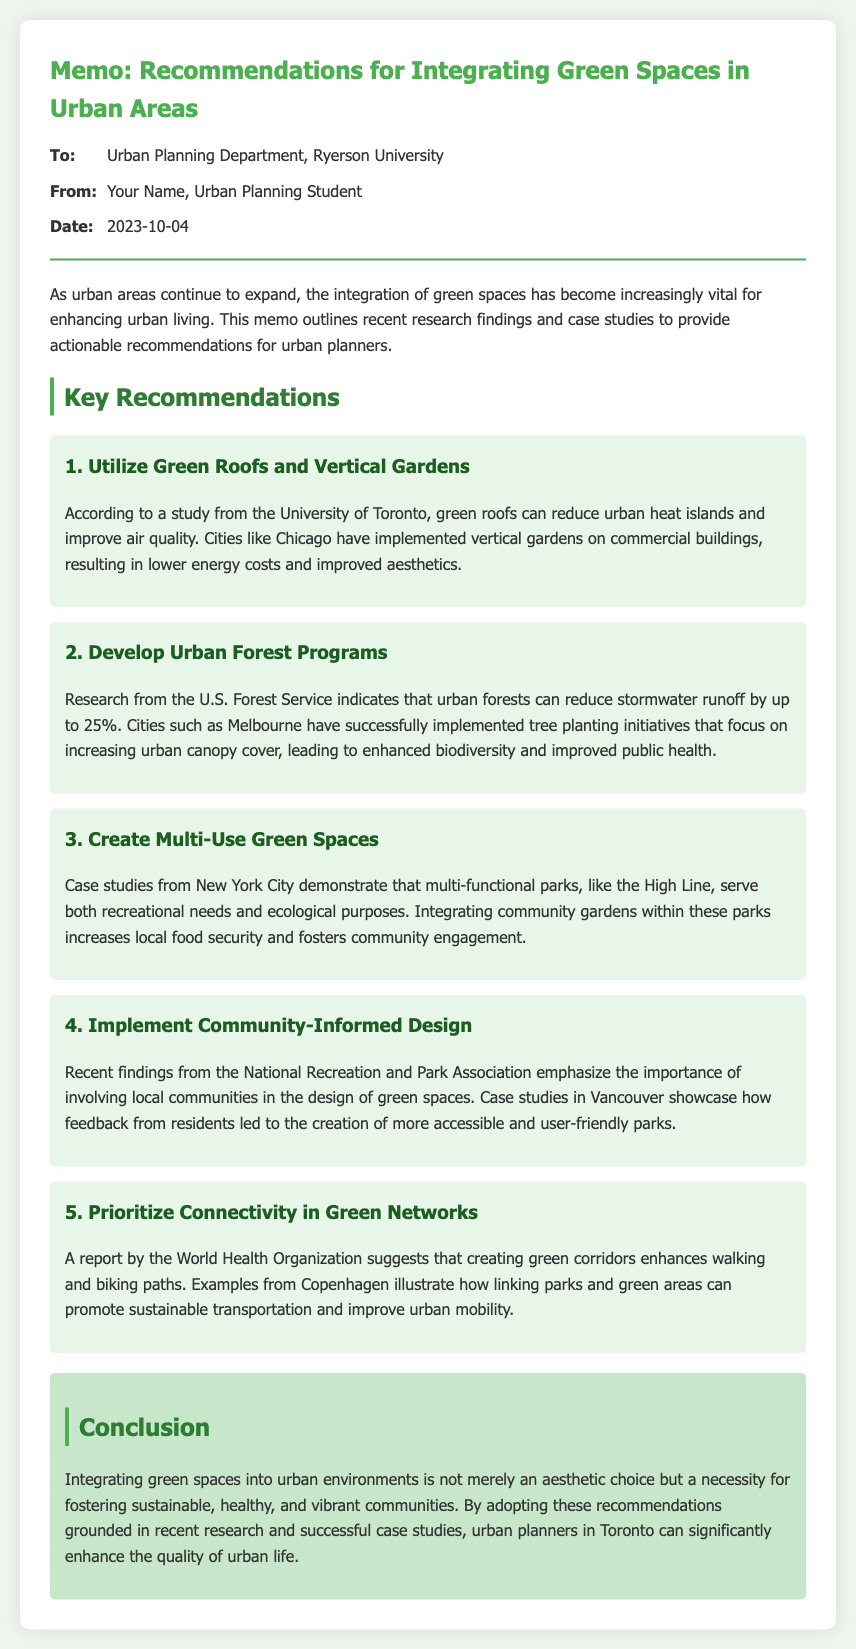what is the date of the memo? The date of the memo is listed in the document's metadata section.
Answer: 2023-10-04 who authored the memo? The author's name is provided in the memo's metadata.
Answer: Your Name, Urban Planning Student which city implemented vertical gardens? The document provides examples of cities that have adopted specific green space strategies.
Answer: Chicago what percentage can urban forests reduce stormwater runoff by? The document states a specific impact percentage from research findings.
Answer: 25% what type of spaces does New York City demonstrate through the High Line? The memo discusses specific functional attributes of parks in New York City.
Answer: Multi-functional parks which organization emphasizes community involvement in green space design? The document cites an authoritative organization relevant to the topic.
Answer: National Recreation and Park Association what is the primary aim of integrating green spaces according to the conclusion? The conclusion summarizes the essential purpose of integrating green spaces in urban areas.
Answer: Fostering sustainable, healthy, and vibrant communities what type of design is recommended to involve local communities? The document mentions a specific approach that incorporates community input.
Answer: Community-Informed Design which city is mentioned for successfully implementing tree planting initiatives? The document provides examples of cities noted for their green space strategies.
Answer: Melbourne 